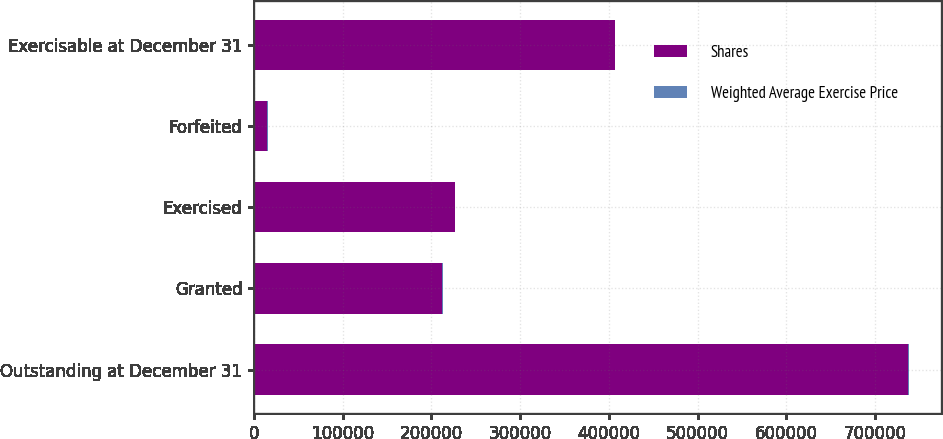<chart> <loc_0><loc_0><loc_500><loc_500><stacked_bar_chart><ecel><fcel>Outstanding at December 31<fcel>Granted<fcel>Exercised<fcel>Forfeited<fcel>Exercisable at December 31<nl><fcel>Shares<fcel>737532<fcel>212420<fcel>226303<fcel>15192<fcel>406687<nl><fcel>Weighted Average Exercise Price<fcel>141.76<fcel>188.73<fcel>44.93<fcel>170.38<fcel>102.53<nl></chart> 